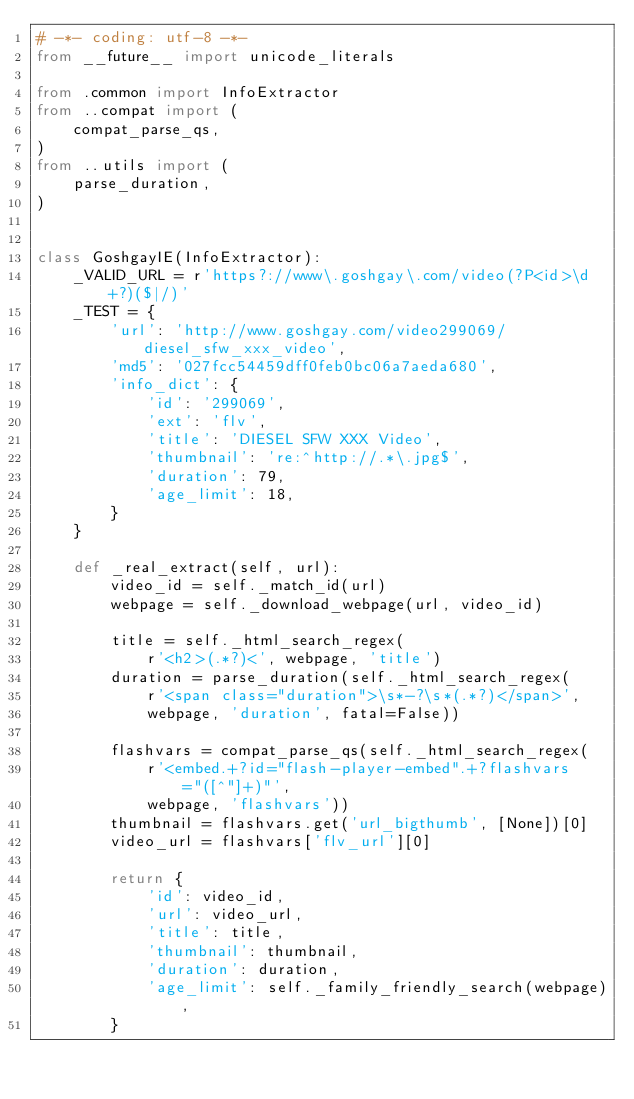Convert code to text. <code><loc_0><loc_0><loc_500><loc_500><_Python_># -*- coding: utf-8 -*-
from __future__ import unicode_literals

from .common import InfoExtractor
from ..compat import (
    compat_parse_qs,
)
from ..utils import (
    parse_duration,
)


class GoshgayIE(InfoExtractor):
    _VALID_URL = r'https?://www\.goshgay\.com/video(?P<id>\d+?)($|/)'
    _TEST = {
        'url': 'http://www.goshgay.com/video299069/diesel_sfw_xxx_video',
        'md5': '027fcc54459dff0feb0bc06a7aeda680',
        'info_dict': {
            'id': '299069',
            'ext': 'flv',
            'title': 'DIESEL SFW XXX Video',
            'thumbnail': 're:^http://.*\.jpg$',
            'duration': 79,
            'age_limit': 18,
        }
    }

    def _real_extract(self, url):
        video_id = self._match_id(url)
        webpage = self._download_webpage(url, video_id)

        title = self._html_search_regex(
            r'<h2>(.*?)<', webpage, 'title')
        duration = parse_duration(self._html_search_regex(
            r'<span class="duration">\s*-?\s*(.*?)</span>',
            webpage, 'duration', fatal=False))

        flashvars = compat_parse_qs(self._html_search_regex(
            r'<embed.+?id="flash-player-embed".+?flashvars="([^"]+)"',
            webpage, 'flashvars'))
        thumbnail = flashvars.get('url_bigthumb', [None])[0]
        video_url = flashvars['flv_url'][0]

        return {
            'id': video_id,
            'url': video_url,
            'title': title,
            'thumbnail': thumbnail,
            'duration': duration,
            'age_limit': self._family_friendly_search(webpage),
        }
</code> 